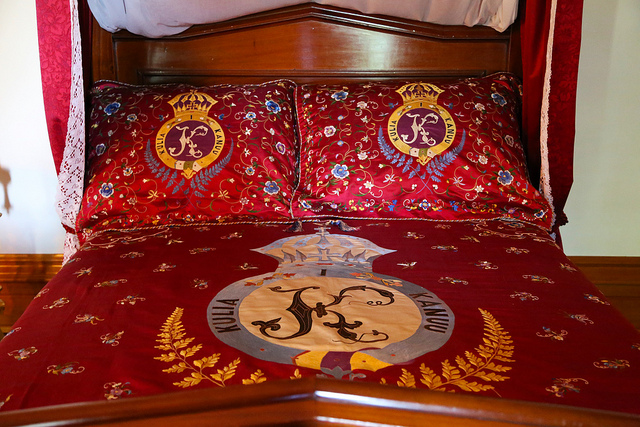Read and extract the text from this image. KULIA KANUU KULIA KANNU KULIA K K K KANNU 